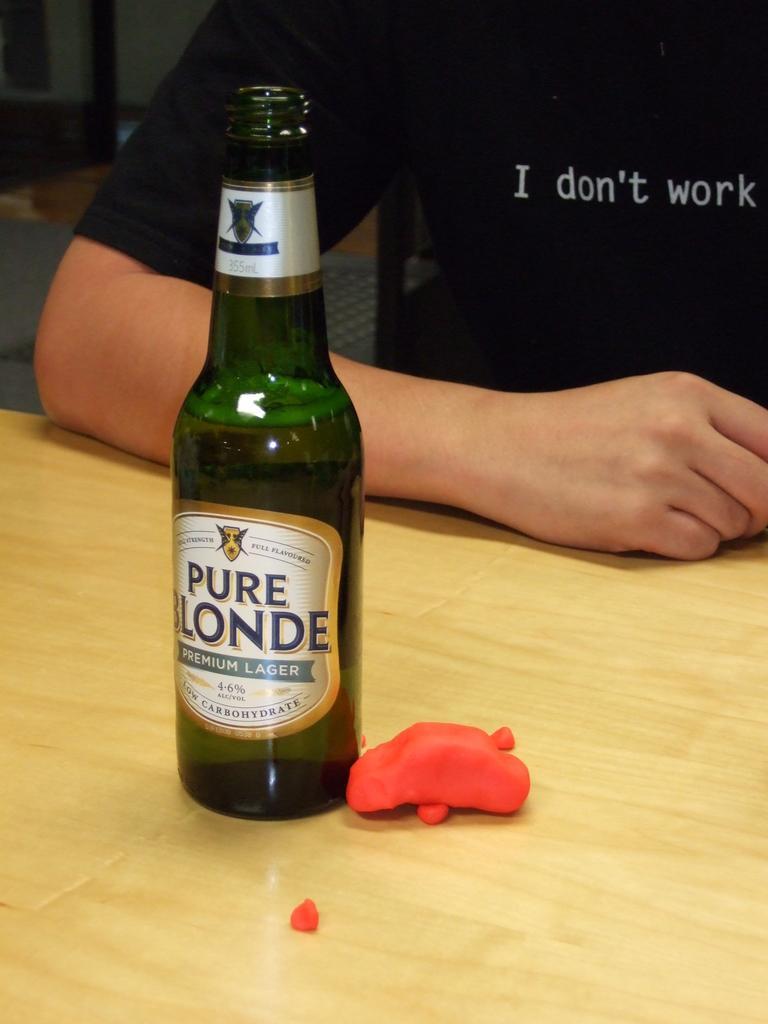Please provide a concise description of this image. In this image i can see a glass bottle on the table and the person who is wearing a black t shirt. 